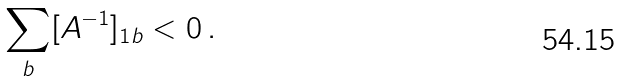<formula> <loc_0><loc_0><loc_500><loc_500>\sum _ { b } [ A ^ { - 1 } ] _ { 1 b } < 0 \, .</formula> 